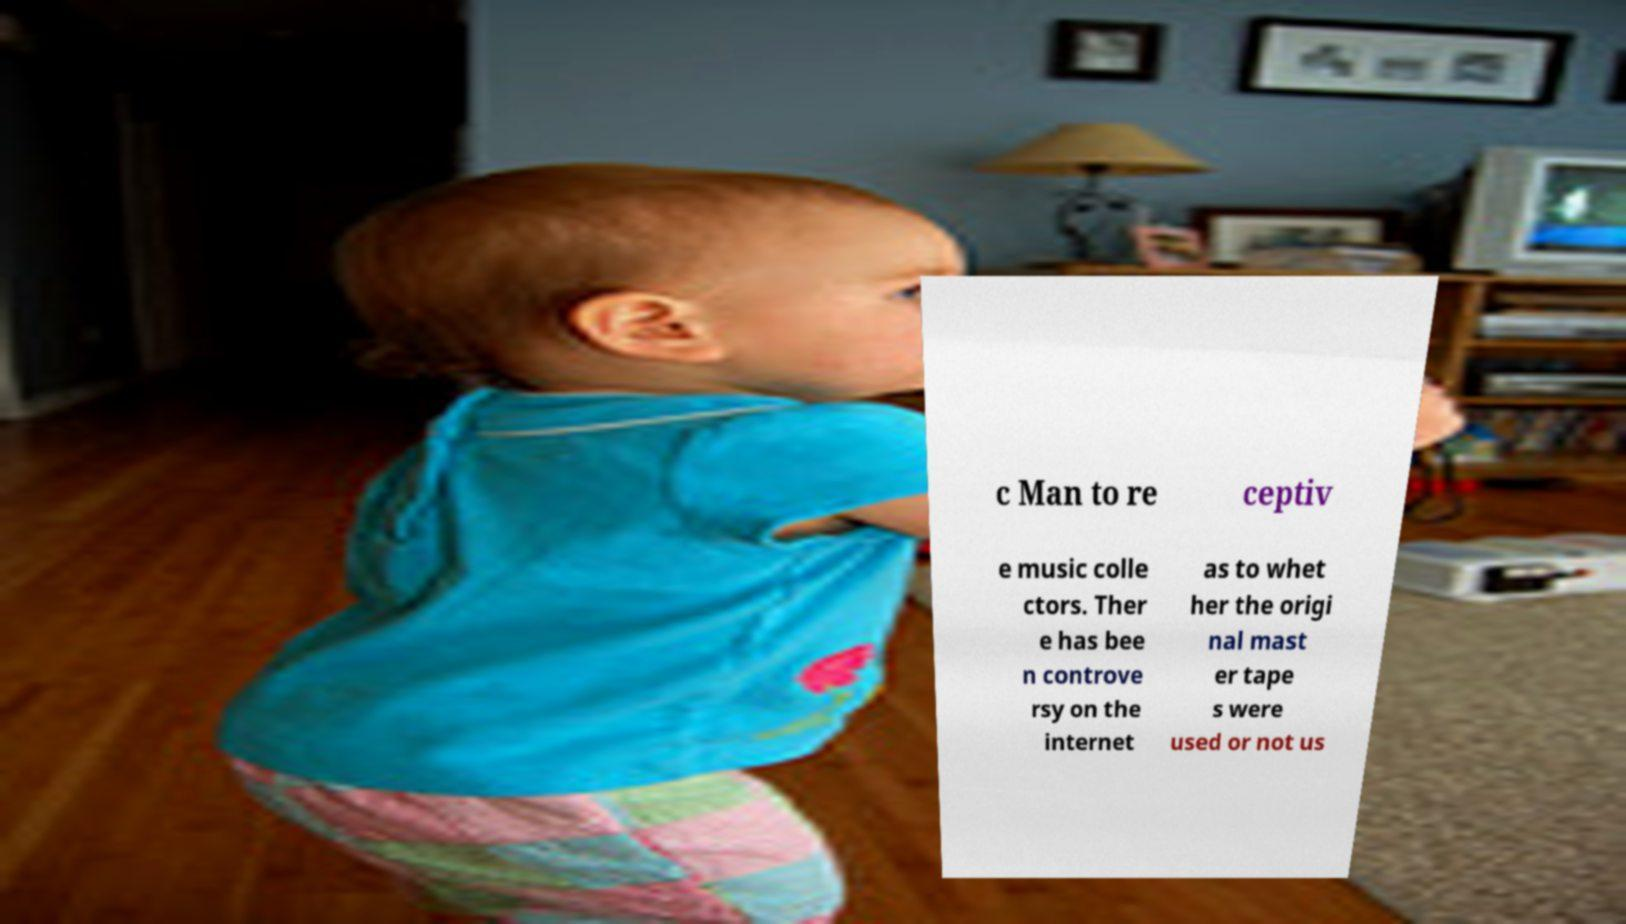For documentation purposes, I need the text within this image transcribed. Could you provide that? c Man to re ceptiv e music colle ctors. Ther e has bee n controve rsy on the internet as to whet her the origi nal mast er tape s were used or not us 